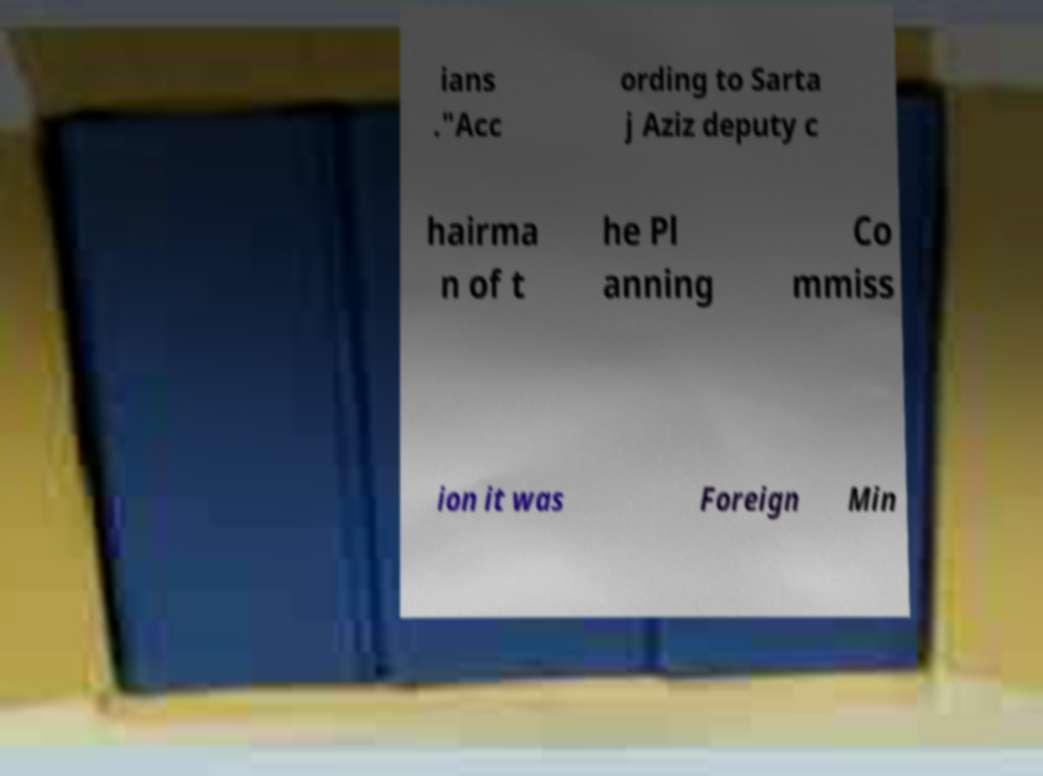There's text embedded in this image that I need extracted. Can you transcribe it verbatim? ians ."Acc ording to Sarta j Aziz deputy c hairma n of t he Pl anning Co mmiss ion it was Foreign Min 